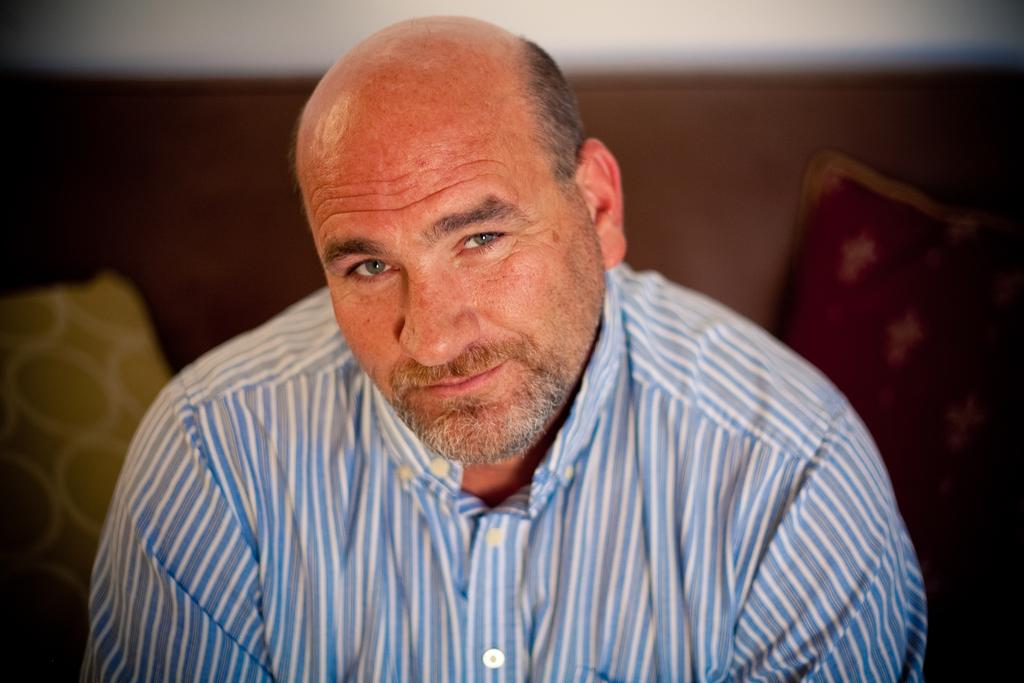Who is present in the image? There is a man in the image. What is the man doing in the image? The man is smiling in the image. What is the man wearing in the image? The man is wearing a shirt in the image. What can be seen in the background of the image? There is a couch in the background of the image. How many cushions are on the couch in the image? The couch has two cushions on it in the image. What type of heart-shaped offer is the man holding in the image? There is no heart-shaped offer present in the image; the man is simply smiling and wearing a shirt. 